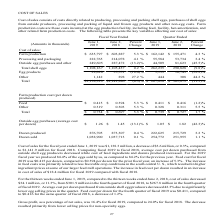Looking at Cal Maine Foods's financial data, please calculate: What is the farm production cost in year ended 2019 as a percentage of total cost? Based on the calculation: 635,797 / 1,138,329, the result is 55.85 (percentage). This is based on the information: "Cost of sales: Farm production $ 635,797 $ 603,887 5.3 % $ 162,142 $ 155,471 4.3 % Processing and packaging 222,765 214,078 4.1 % 55,584 53, .2)% Other 1,142 898 27.2 % 444 308 44.2 % Total $1,138,329..." The key data points involved are: 1,138,329, 635,797. Also, What was the reason for increase in feed costs in 2019? increase in feed costs was primarily related to less favorable crop conditions in the south central U. S., which resulted in higher ingredient prices at some of our larger feed mill operations.. The document states: "or the prior fiscal year, an increase of 5.3%. The increase in feed costs was primarily related to less favorable crop conditions in the south central..." Also, What was the rationale of decrease in average cost per dozen purchased from outside shell egg producers? due to significantly lower egg selling prices in the quarter. The document states: "from outside shell egg producers decreased 42.3% due to significantly lower egg selling prices in the quarter. Feed cost per dozen for the fourth quar..." Also, What was the increase / (decrease) in dozen produced in 2019 compared to 2018?  According to the financial document, 0.4%. The relevant text states: ".05 $ 1.82 (42.3)% Dozen produced 876,705 873,307 0.4 % 222,625 215,729 3.2 % Dozen sold 1,038,900 1,037,713 0.1 % 254,772 251,955 1.1 %..." Also, can you calculate: What percentage of total cost does Egg products form a part of in 2019? Based on the calculation: 29,020 / $1,138,329, the result is 2.55 (percentage). This is based on the information: ".2)% Other 1,142 898 27.2 % 444 308 44.2 % Total $1,138,329 $1,141,886 (0.3)% $ 267,818 $ 301,879 (11.3)% Farm production cost (per dozen produced) Feed $ 0.41 105,437 0.2 % 262,235 290,828 (9.8)% Egg..." The key data points involved are: 1,138,329, 29,020. Also, can you calculate: What is the cost of sales per dozen produced in year ended 2019? Based on the calculation: 1,138,329 / 876,705, the result is 1.3 (in thousands). This is based on the information: ".2)% Other 1,142 898 27.2 % 444 308 44.2 % Total $1,138,329 $1,141,886 (0.3)% $ 267,818 $ 301,879 (11.3)% Farm production cost (per dozen produced) Feed $ 0.41 1.45 (13.1)% $ 1.05 $ 1.82 (42.3)% Dozen..." The key data points involved are: 1,138,329, 876,705. 